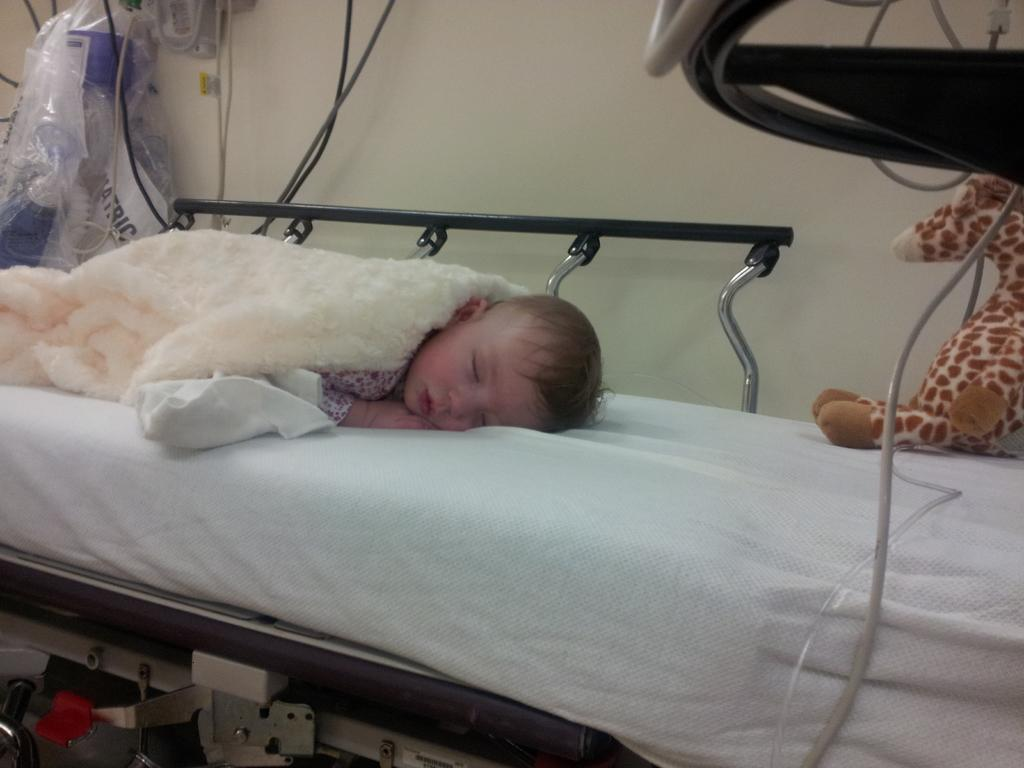What is the main subject of the image? The main subject of the image is a baby sleeping on the bed. What else can be seen in the image besides the baby? There is a toy, a blanket, a wire, a wall, covers, and metal rods in the background of the image. What is the purpose of the blanket in the image? The blanket is likely used to keep the baby warm while sleeping. What type of room might the image be taken in? The image is likely taken in a room, possibly a bedroom, given the presence of a bed and other furniture. What type of learning is taking place on the farm in the image? There is no farm or learning activity present in the image; it features a baby sleeping on a bed with various objects in the background. 